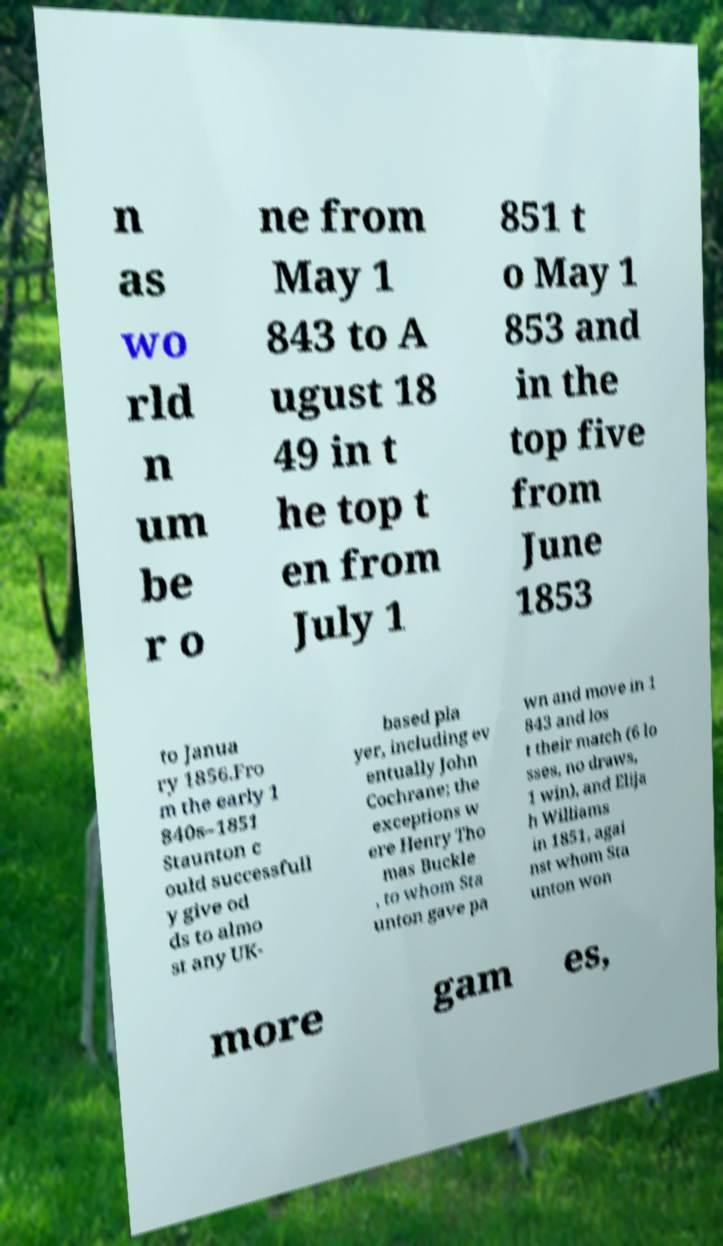Can you read and provide the text displayed in the image?This photo seems to have some interesting text. Can you extract and type it out for me? n as wo rld n um be r o ne from May 1 843 to A ugust 18 49 in t he top t en from July 1 851 t o May 1 853 and in the top five from June 1853 to Janua ry 1856.Fro m the early 1 840s–1851 Staunton c ould successfull y give od ds to almo st any UK- based pla yer, including ev entually John Cochrane; the exceptions w ere Henry Tho mas Buckle , to whom Sta unton gave pa wn and move in 1 843 and los t their match (6 lo sses, no draws, 1 win), and Elija h Williams in 1851, agai nst whom Sta unton won more gam es, 